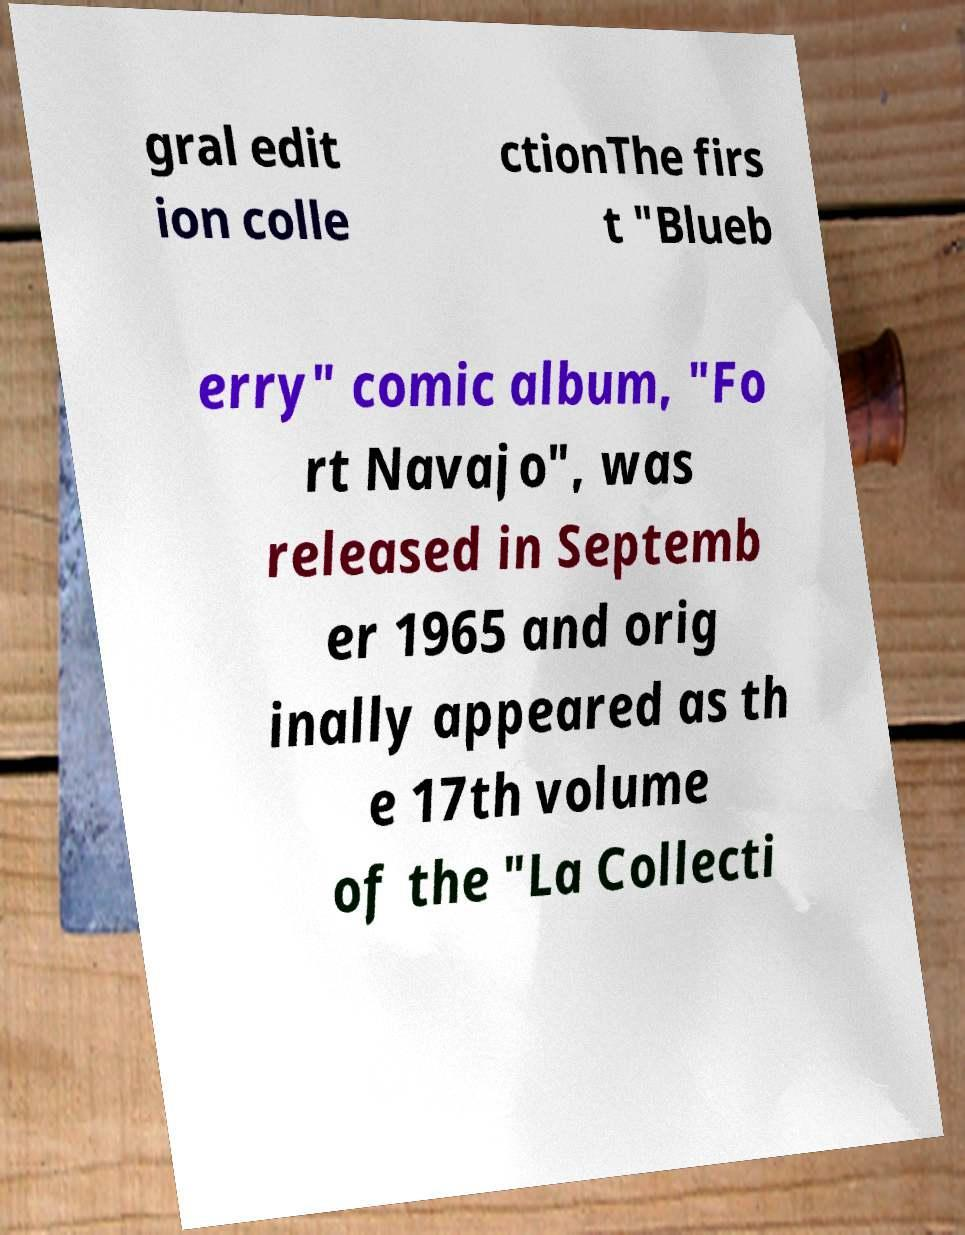Could you extract and type out the text from this image? gral edit ion colle ctionThe firs t "Blueb erry" comic album, "Fo rt Navajo", was released in Septemb er 1965 and orig inally appeared as th e 17th volume of the "La Collecti 